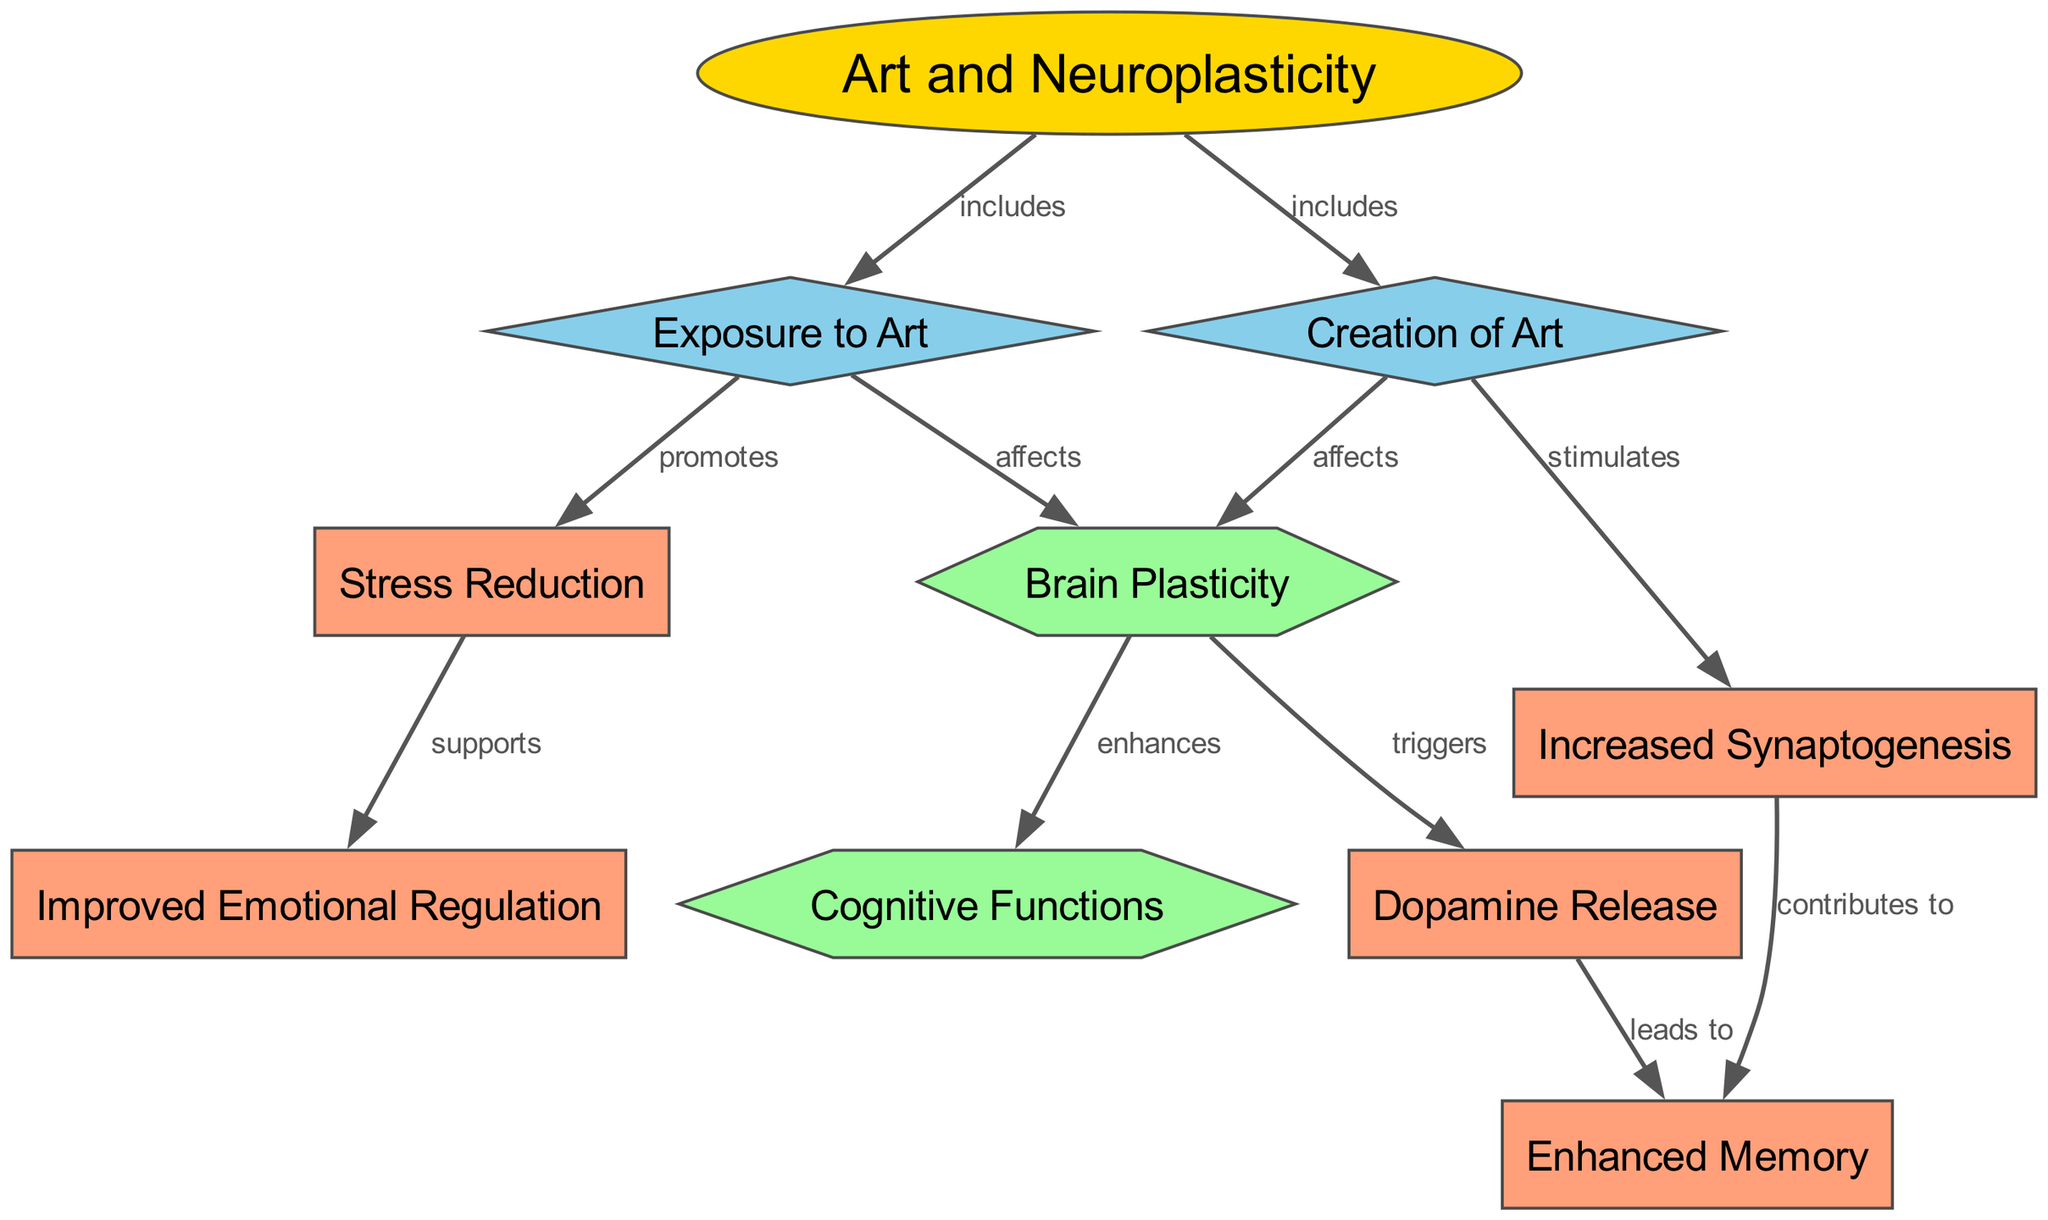What are the two primary components of art related to neuroplasticity? The diagram shows two primary components linked to "Art and Neuroplasticity": "Exposure to Art" and "Creation of Art," connected by edges labeled "includes."
Answer: Exposure to Art, Creation of Art How many nodes are there in the diagram? By counting the listed nodes, there are ten distinct nodes that represent various concepts related to art and neuroplasticity.
Answer: 10 What effect does exposure to art have on brain plasticity? The diagram states that "Exposure to Art" affects "Brain Plasticity," indicating a direct influence as depicted by the labeled edge.
Answer: Affects What triggers dopamine release in the diagram? The diagram specifies that "Brain Plasticity" triggers "Dopamine Release," as indicated by the labeled edge connecting these two nodes.
Answer: Brain Plasticity How does creation of art contribute to enhanced memory? The diagram presents a flow where "Creation of Art" stimulates "Increased Synaptogenesis," and then "Increased Synaptogenesis" contributes to "Enhanced Memory," reflecting a pathway of influence.
Answer: Contributes to What support does stress reduction provide according to the diagram? The diagram indicates that "Stress Reduction" supports "Improved Emotional Regulation," showing a direct relationship through the labeled edge between these nodes.
Answer: Supports How does exposure to art relate to cognitive functions? The diagram shows that both "Exposure to Art" and "Creation of Art" lead to "Brain Plasticity," which subsequently enhances "Cognitive Functions," reflecting a cascading effect.
Answer: Enhances What kind of relationship exists between dopamine release and enhanced memory? The diagram indicates a direct cause-and-effect relationship where "Dopamine Release" leads to "Enhanced Memory," highlighted by the connecting edge labeled "leads to."
Answer: Leads to 